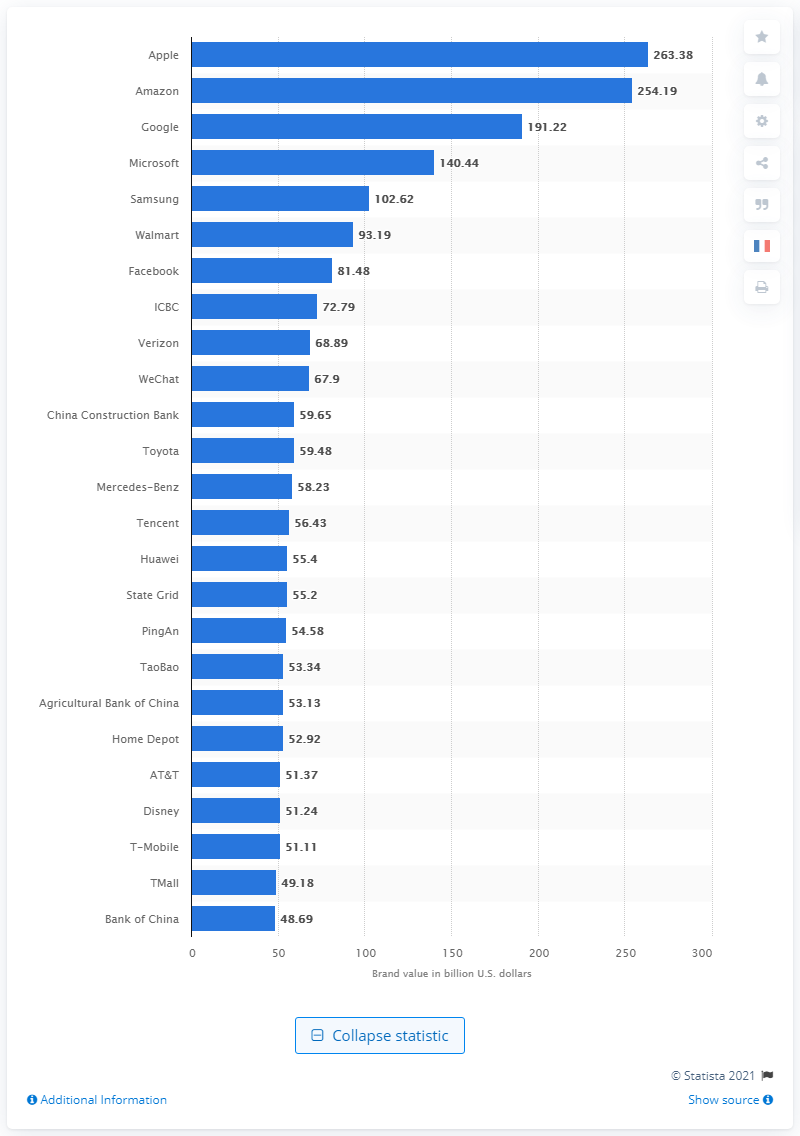Outline some significant characteristics in this image. Amazon's brand value in dollars in 2021 was 254.19. In 2021, Apple was recognized as the most valuable brand in the world. According to reports, Amazon was the second leading brand in the world in 2021. 